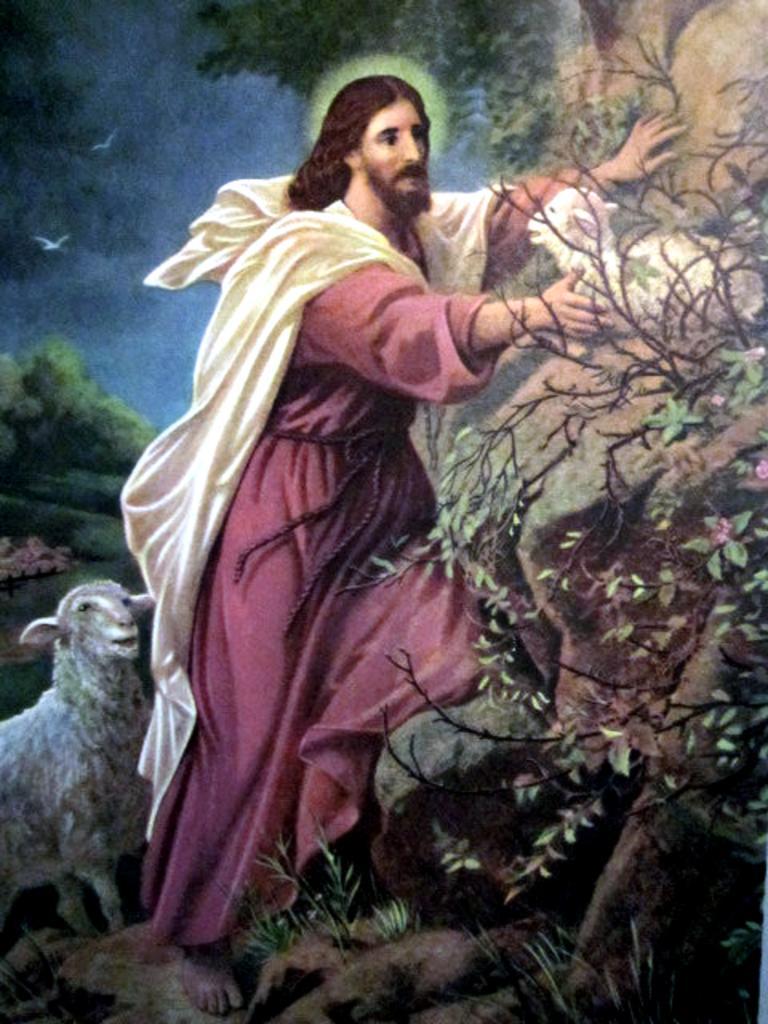How would you summarize this image in a sentence or two? In the image I can see a person standing beside the rock and also I can see some birds, sheep, trees and some other things. 